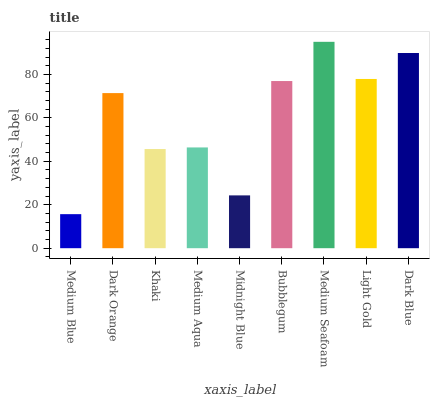Is Medium Blue the minimum?
Answer yes or no. Yes. Is Medium Seafoam the maximum?
Answer yes or no. Yes. Is Dark Orange the minimum?
Answer yes or no. No. Is Dark Orange the maximum?
Answer yes or no. No. Is Dark Orange greater than Medium Blue?
Answer yes or no. Yes. Is Medium Blue less than Dark Orange?
Answer yes or no. Yes. Is Medium Blue greater than Dark Orange?
Answer yes or no. No. Is Dark Orange less than Medium Blue?
Answer yes or no. No. Is Dark Orange the high median?
Answer yes or no. Yes. Is Dark Orange the low median?
Answer yes or no. Yes. Is Bubblegum the high median?
Answer yes or no. No. Is Medium Aqua the low median?
Answer yes or no. No. 